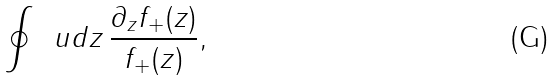<formula> <loc_0><loc_0><loc_500><loc_500>\oint \, \ u d z \, \frac { \partial _ { z } f _ { + } ( z ) } { f _ { + } ( z ) } ,</formula> 